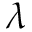<formula> <loc_0><loc_0><loc_500><loc_500>\lambda</formula> 